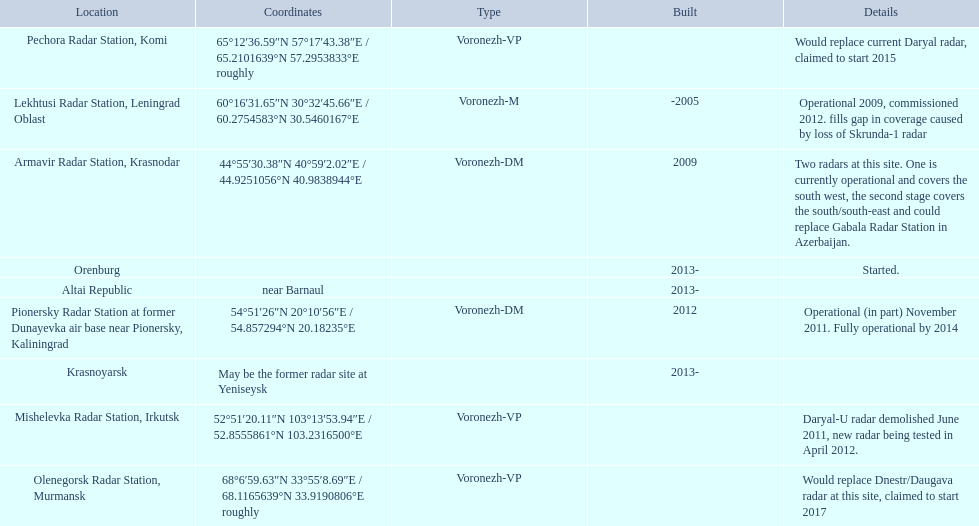Write the full table. {'header': ['Location', 'Coordinates', 'Type', 'Built', 'Details'], 'rows': [['Pechora Radar Station, Komi', '65°12′36.59″N 57°17′43.38″E\ufeff / \ufeff65.2101639°N 57.2953833°E roughly', 'Voronezh-VP', '', 'Would replace current Daryal radar, claimed to start 2015'], ['Lekhtusi Radar Station, Leningrad Oblast', '60°16′31.65″N 30°32′45.66″E\ufeff / \ufeff60.2754583°N 30.5460167°E', 'Voronezh-M', '-2005', 'Operational 2009, commissioned 2012. fills gap in coverage caused by loss of Skrunda-1 radar'], ['Armavir Radar Station, Krasnodar', '44°55′30.38″N 40°59′2.02″E\ufeff / \ufeff44.9251056°N 40.9838944°E', 'Voronezh-DM', '2009', 'Two radars at this site. One is currently operational and covers the south west, the second stage covers the south/south-east and could replace Gabala Radar Station in Azerbaijan.'], ['Orenburg', '', '', '2013-', 'Started.'], ['Altai Republic', 'near Barnaul', '', '2013-', ''], ['Pionersky Radar Station at former Dunayevka air base near Pionersky, Kaliningrad', '54°51′26″N 20°10′56″E\ufeff / \ufeff54.857294°N 20.18235°E', 'Voronezh-DM', '2012', 'Operational (in part) November 2011. Fully operational by 2014'], ['Krasnoyarsk', 'May be the former radar site at Yeniseysk', '', '2013-', ''], ['Mishelevka Radar Station, Irkutsk', '52°51′20.11″N 103°13′53.94″E\ufeff / \ufeff52.8555861°N 103.2316500°E', 'Voronezh-VP', '', 'Daryal-U radar demolished June 2011, new radar being tested in April 2012.'], ['Olenegorsk Radar Station, Murmansk', '68°6′59.63″N 33°55′8.69″E\ufeff / \ufeff68.1165639°N 33.9190806°E roughly', 'Voronezh-VP', '', 'Would replace Dnestr/Daugava radar at this site, claimed to start 2017']]} Where is each radar? Lekhtusi Radar Station, Leningrad Oblast, Armavir Radar Station, Krasnodar, Pionersky Radar Station at former Dunayevka air base near Pionersky, Kaliningrad, Mishelevka Radar Station, Irkutsk, Pechora Radar Station, Komi, Olenegorsk Radar Station, Murmansk, Krasnoyarsk, Altai Republic, Orenburg. What are the details of each radar? Operational 2009, commissioned 2012. fills gap in coverage caused by loss of Skrunda-1 radar, Two radars at this site. One is currently operational and covers the south west, the second stage covers the south/south-east and could replace Gabala Radar Station in Azerbaijan., Operational (in part) November 2011. Fully operational by 2014, Daryal-U radar demolished June 2011, new radar being tested in April 2012., Would replace current Daryal radar, claimed to start 2015, Would replace Dnestr/Daugava radar at this site, claimed to start 2017, , , Started. Which radar is detailed to start in 2015? Pechora Radar Station, Komi. 